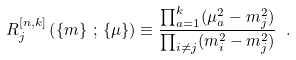<formula> <loc_0><loc_0><loc_500><loc_500>R _ { j } ^ { [ n , k ] } \left ( \left \{ m \right \} \, ; \, \left \{ \mu \right \} \right ) \equiv \frac { \prod _ { a = 1 } ^ { k } ( \mu ^ { 2 } _ { a } - m ^ { 2 } _ { j } ) } { \prod _ { i \not = j } ( m ^ { 2 } _ { i } - m ^ { 2 } _ { j } ) } \ .</formula> 